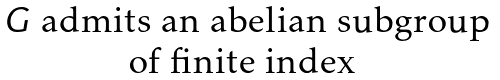<formula> <loc_0><loc_0><loc_500><loc_500>\begin{matrix} G \text { admits an abelian subgroup} \\ \text {of finite index } \end{matrix}</formula> 